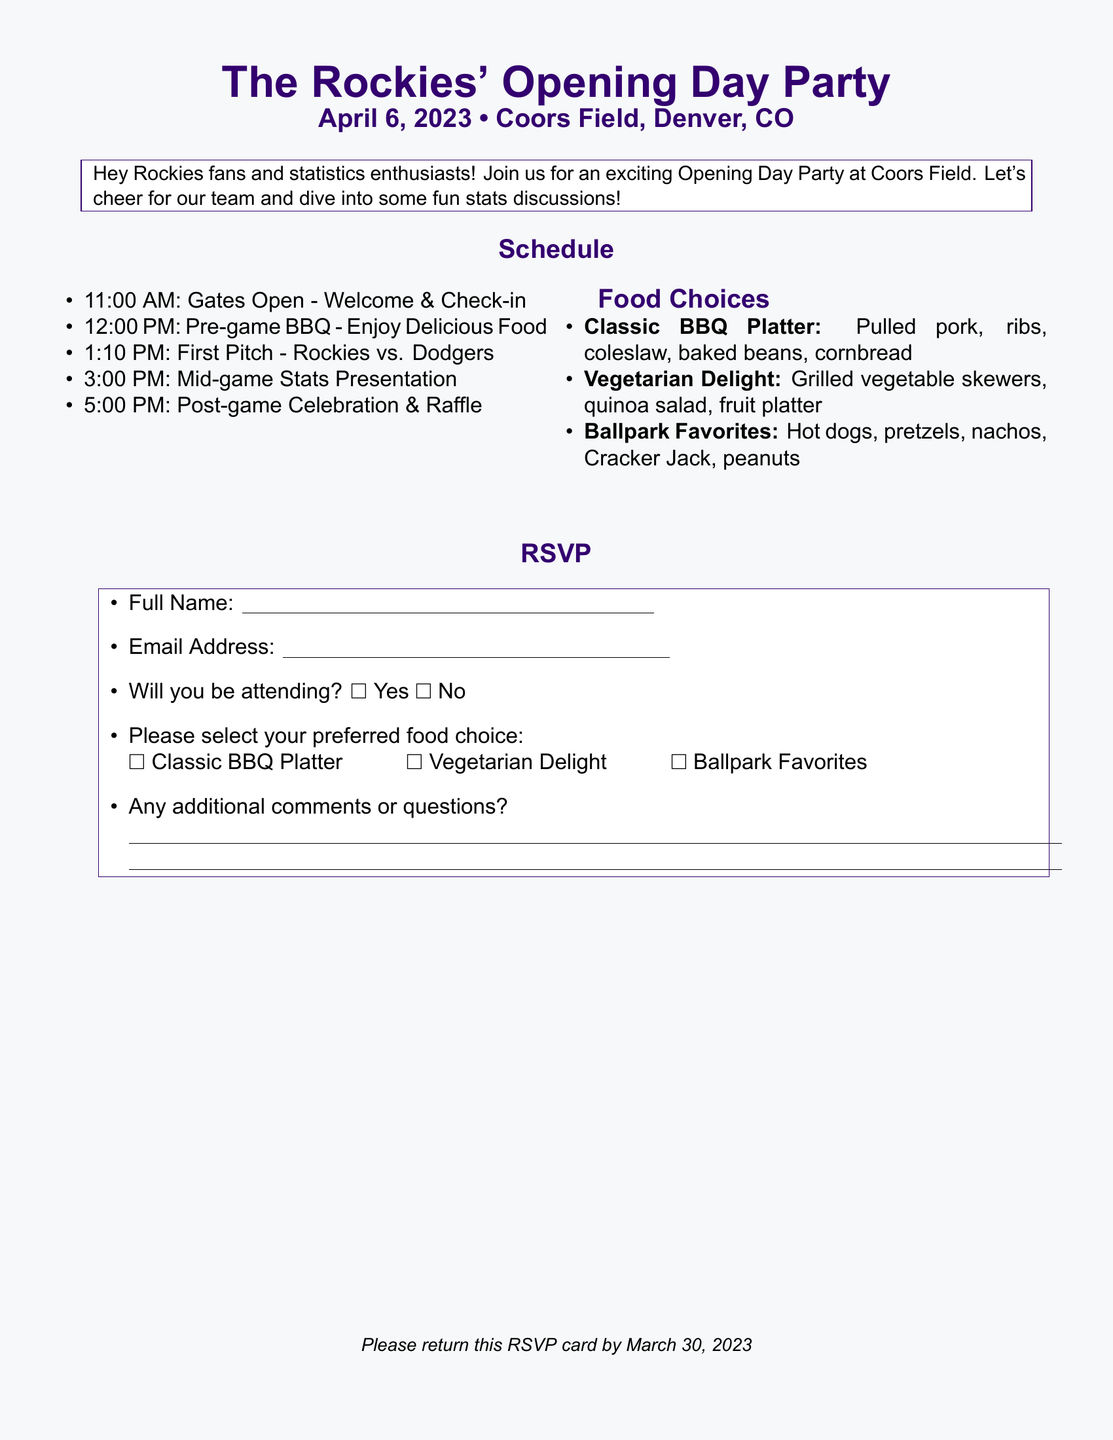what is the date of the Opening Day Party? The date of the Opening Day Party is stated in the document.
Answer: April 6, 2023 what time do the gates open? The document lists the schedule which includes the opening time for the gates.
Answer: 11:00 AM what team are the Rockies playing on Opening Day? The document mentions the game details including the opposing team.
Answer: Dodgers what type of BBQ is offered in the food choices? The food choices section specifies the different BBQ options available at the event.
Answer: Classic BBQ Platter what is the last scheduled event of the day? By looking at the schedule, the last event is identified.
Answer: Post-game Celebration & Raffle how many food options are provided? The food choices section lists the various meal options available for attendees.
Answer: Three what is the deadline to return the RSVP card? The document clearly states the deadline for returning the RSVP.
Answer: March 30, 2023 what should attendees include with their RSVP regarding food? The RSVP section specifies what attendees need to select related to food choices.
Answer: Preferred food choice will attendees have access to a mid-game presentation? The schedule outlines the events scheduled during the game, indicating a presentation.
Answer: Yes 